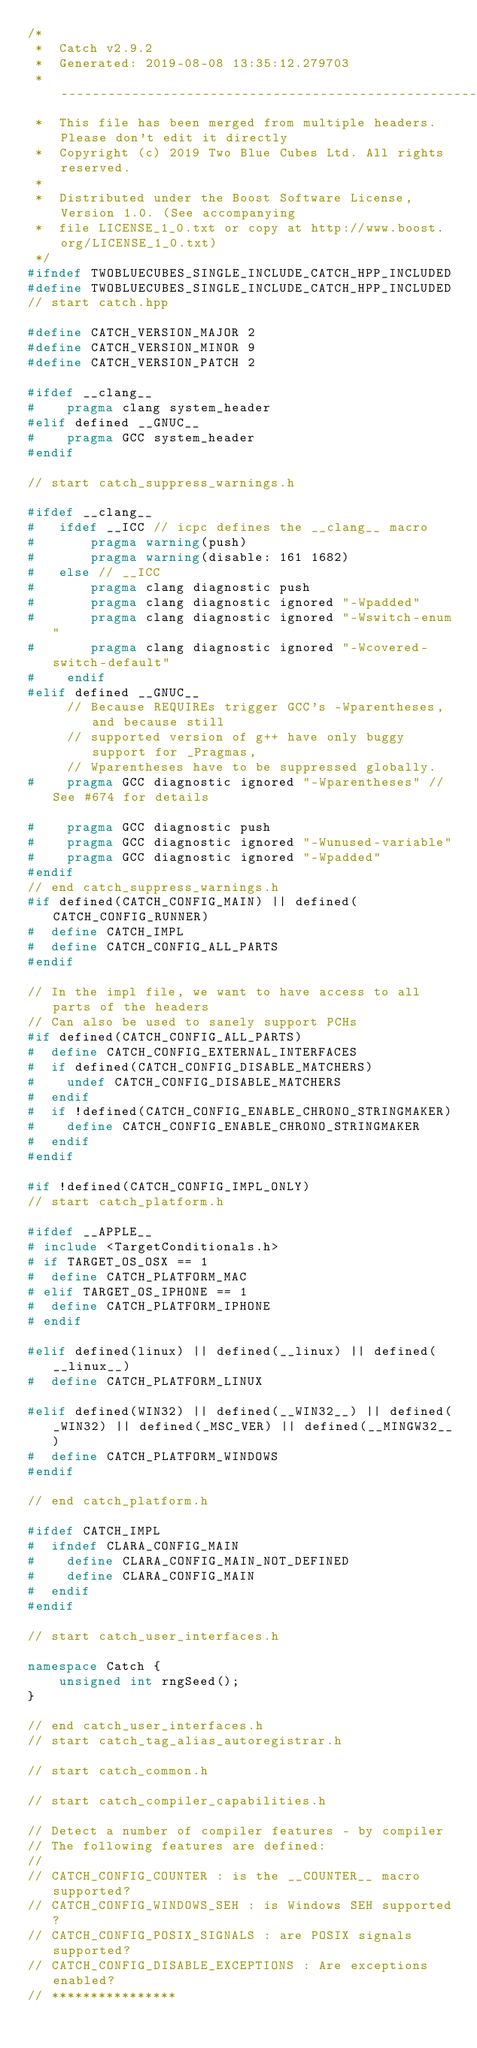Convert code to text. <code><loc_0><loc_0><loc_500><loc_500><_C++_>/*
 *  Catch v2.9.2
 *  Generated: 2019-08-08 13:35:12.279703
 *  ----------------------------------------------------------
 *  This file has been merged from multiple headers. Please don't edit it directly
 *  Copyright (c) 2019 Two Blue Cubes Ltd. All rights reserved.
 *
 *  Distributed under the Boost Software License, Version 1.0. (See accompanying
 *  file LICENSE_1_0.txt or copy at http://www.boost.org/LICENSE_1_0.txt)
 */
#ifndef TWOBLUECUBES_SINGLE_INCLUDE_CATCH_HPP_INCLUDED
#define TWOBLUECUBES_SINGLE_INCLUDE_CATCH_HPP_INCLUDED
// start catch.hpp

#define CATCH_VERSION_MAJOR 2
#define CATCH_VERSION_MINOR 9
#define CATCH_VERSION_PATCH 2

#ifdef __clang__
#    pragma clang system_header
#elif defined __GNUC__
#    pragma GCC system_header
#endif

// start catch_suppress_warnings.h

#ifdef __clang__
#   ifdef __ICC // icpc defines the __clang__ macro
#       pragma warning(push)
#       pragma warning(disable: 161 1682)
#   else // __ICC
#       pragma clang diagnostic push
#       pragma clang diagnostic ignored "-Wpadded"
#       pragma clang diagnostic ignored "-Wswitch-enum"
#       pragma clang diagnostic ignored "-Wcovered-switch-default"
#    endif
#elif defined __GNUC__
     // Because REQUIREs trigger GCC's -Wparentheses, and because still
     // supported version of g++ have only buggy support for _Pragmas,
     // Wparentheses have to be suppressed globally.
#    pragma GCC diagnostic ignored "-Wparentheses" // See #674 for details

#    pragma GCC diagnostic push
#    pragma GCC diagnostic ignored "-Wunused-variable"
#    pragma GCC diagnostic ignored "-Wpadded"
#endif
// end catch_suppress_warnings.h
#if defined(CATCH_CONFIG_MAIN) || defined(CATCH_CONFIG_RUNNER)
#  define CATCH_IMPL
#  define CATCH_CONFIG_ALL_PARTS
#endif

// In the impl file, we want to have access to all parts of the headers
// Can also be used to sanely support PCHs
#if defined(CATCH_CONFIG_ALL_PARTS)
#  define CATCH_CONFIG_EXTERNAL_INTERFACES
#  if defined(CATCH_CONFIG_DISABLE_MATCHERS)
#    undef CATCH_CONFIG_DISABLE_MATCHERS
#  endif
#  if !defined(CATCH_CONFIG_ENABLE_CHRONO_STRINGMAKER)
#    define CATCH_CONFIG_ENABLE_CHRONO_STRINGMAKER
#  endif
#endif

#if !defined(CATCH_CONFIG_IMPL_ONLY)
// start catch_platform.h

#ifdef __APPLE__
# include <TargetConditionals.h>
# if TARGET_OS_OSX == 1
#  define CATCH_PLATFORM_MAC
# elif TARGET_OS_IPHONE == 1
#  define CATCH_PLATFORM_IPHONE
# endif

#elif defined(linux) || defined(__linux) || defined(__linux__)
#  define CATCH_PLATFORM_LINUX

#elif defined(WIN32) || defined(__WIN32__) || defined(_WIN32) || defined(_MSC_VER) || defined(__MINGW32__)
#  define CATCH_PLATFORM_WINDOWS
#endif

// end catch_platform.h

#ifdef CATCH_IMPL
#  ifndef CLARA_CONFIG_MAIN
#    define CLARA_CONFIG_MAIN_NOT_DEFINED
#    define CLARA_CONFIG_MAIN
#  endif
#endif

// start catch_user_interfaces.h

namespace Catch {
    unsigned int rngSeed();
}

// end catch_user_interfaces.h
// start catch_tag_alias_autoregistrar.h

// start catch_common.h

// start catch_compiler_capabilities.h

// Detect a number of compiler features - by compiler
// The following features are defined:
//
// CATCH_CONFIG_COUNTER : is the __COUNTER__ macro supported?
// CATCH_CONFIG_WINDOWS_SEH : is Windows SEH supported?
// CATCH_CONFIG_POSIX_SIGNALS : are POSIX signals supported?
// CATCH_CONFIG_DISABLE_EXCEPTIONS : Are exceptions enabled?
// ****************</code> 